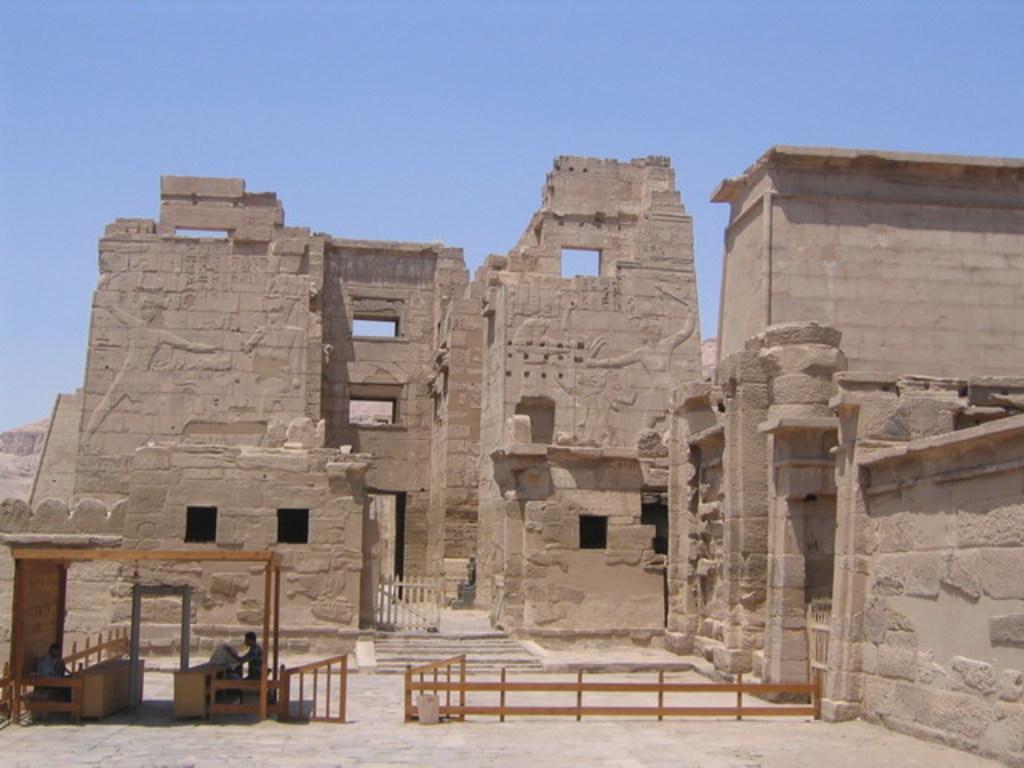How would you summarize this image in a sentence or two? In the picture we can see a historical construction wall and in front of it, we can see a wooden railing with gate and two people are sitting on the chairs near the desk and in the background we can see a sky. 